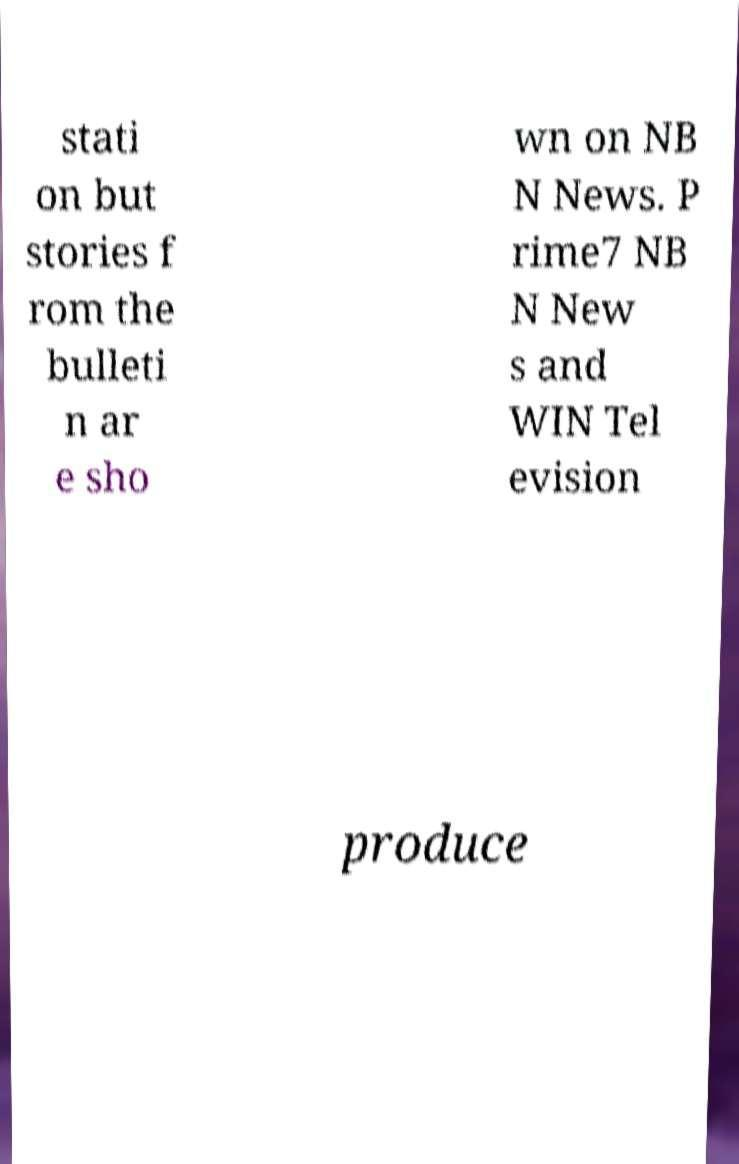Please identify and transcribe the text found in this image. stati on but stories f rom the bulleti n ar e sho wn on NB N News. P rime7 NB N New s and WIN Tel evision produce 